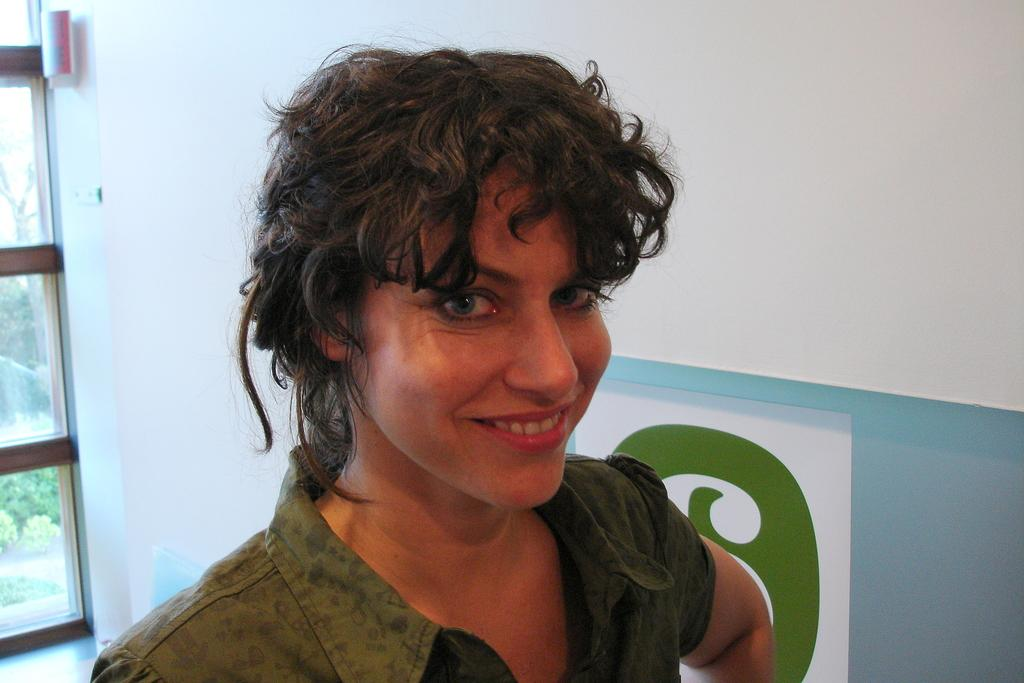Who is present in the image? There is a woman in the image. What is the woman doing in the image? The woman is smiling in the image. What is the woman wearing in the image? The woman is wearing a green color shirt in the image. What can be seen in the background of the image? There is a window and a white wall in the background of the image. What day of the week is depicted in the image? The day of the week is not depicted in the image; it only shows a woman smiling and the background elements. 